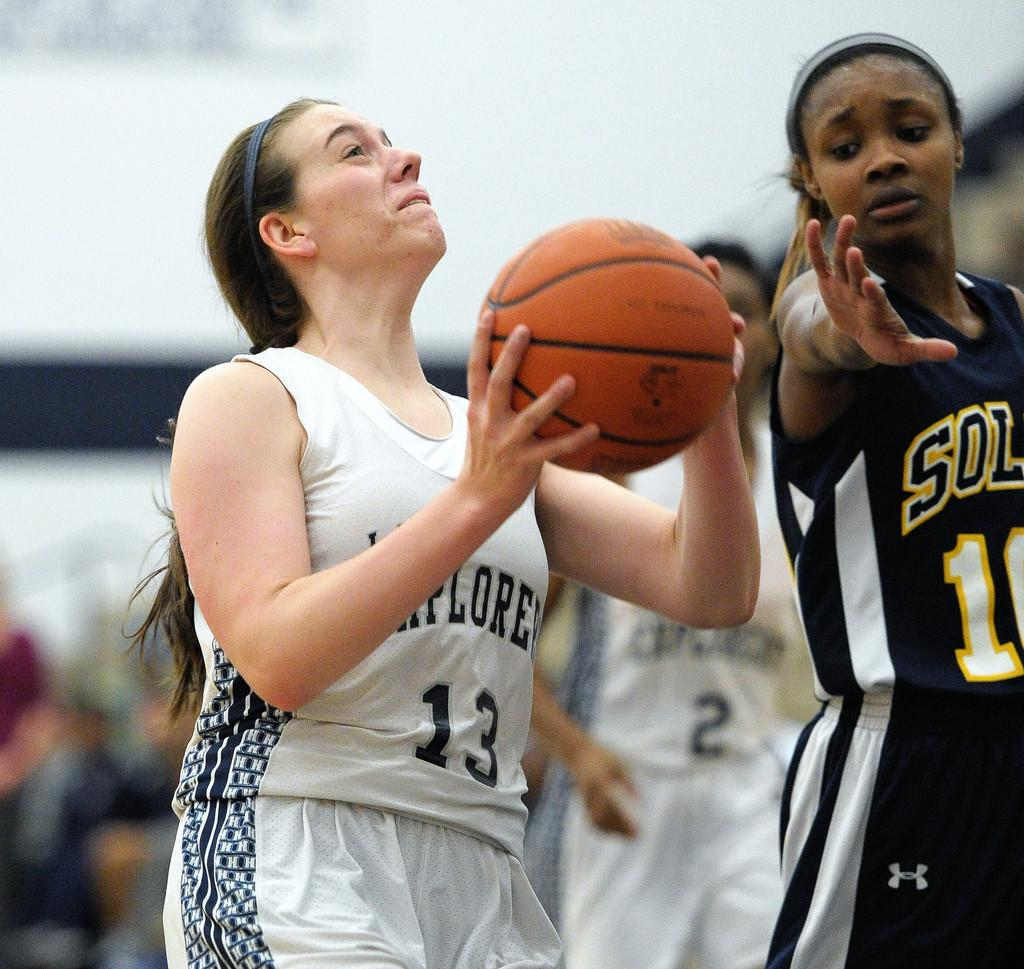<image>
Write a terse but informative summary of the picture. a woman in a number 13 jersey attempts to make a basket 